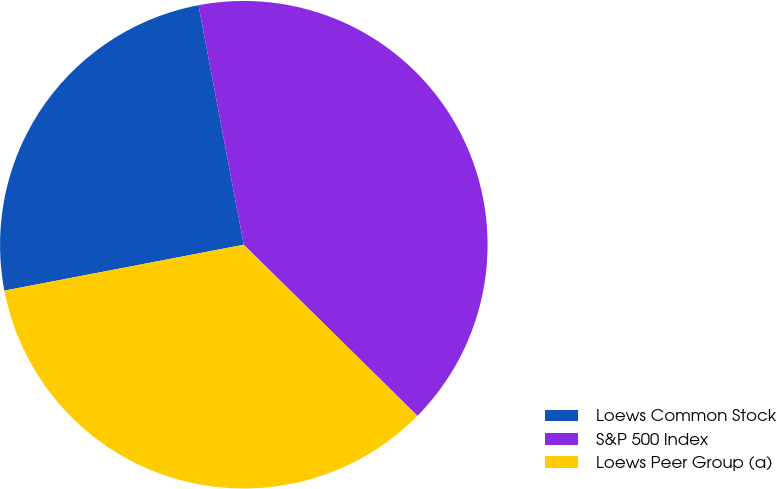Convert chart. <chart><loc_0><loc_0><loc_500><loc_500><pie_chart><fcel>Loews Common Stock<fcel>S&P 500 Index<fcel>Loews Peer Group (a)<nl><fcel>25.04%<fcel>40.36%<fcel>34.6%<nl></chart> 